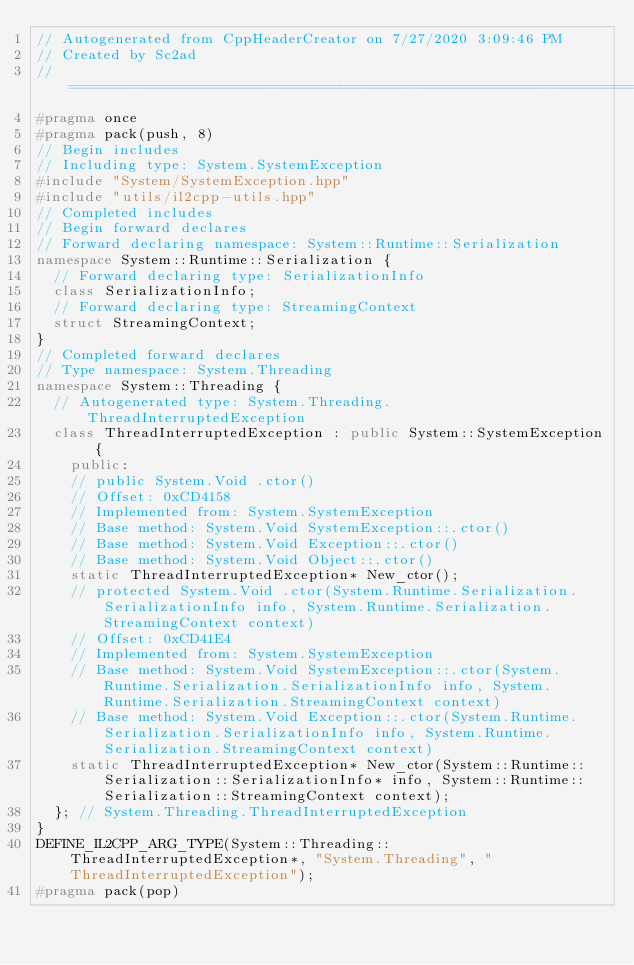<code> <loc_0><loc_0><loc_500><loc_500><_C++_>// Autogenerated from CppHeaderCreator on 7/27/2020 3:09:46 PM
// Created by Sc2ad
// =========================================================================
#pragma once
#pragma pack(push, 8)
// Begin includes
// Including type: System.SystemException
#include "System/SystemException.hpp"
#include "utils/il2cpp-utils.hpp"
// Completed includes
// Begin forward declares
// Forward declaring namespace: System::Runtime::Serialization
namespace System::Runtime::Serialization {
  // Forward declaring type: SerializationInfo
  class SerializationInfo;
  // Forward declaring type: StreamingContext
  struct StreamingContext;
}
// Completed forward declares
// Type namespace: System.Threading
namespace System::Threading {
  // Autogenerated type: System.Threading.ThreadInterruptedException
  class ThreadInterruptedException : public System::SystemException {
    public:
    // public System.Void .ctor()
    // Offset: 0xCD4158
    // Implemented from: System.SystemException
    // Base method: System.Void SystemException::.ctor()
    // Base method: System.Void Exception::.ctor()
    // Base method: System.Void Object::.ctor()
    static ThreadInterruptedException* New_ctor();
    // protected System.Void .ctor(System.Runtime.Serialization.SerializationInfo info, System.Runtime.Serialization.StreamingContext context)
    // Offset: 0xCD41E4
    // Implemented from: System.SystemException
    // Base method: System.Void SystemException::.ctor(System.Runtime.Serialization.SerializationInfo info, System.Runtime.Serialization.StreamingContext context)
    // Base method: System.Void Exception::.ctor(System.Runtime.Serialization.SerializationInfo info, System.Runtime.Serialization.StreamingContext context)
    static ThreadInterruptedException* New_ctor(System::Runtime::Serialization::SerializationInfo* info, System::Runtime::Serialization::StreamingContext context);
  }; // System.Threading.ThreadInterruptedException
}
DEFINE_IL2CPP_ARG_TYPE(System::Threading::ThreadInterruptedException*, "System.Threading", "ThreadInterruptedException");
#pragma pack(pop)
</code> 